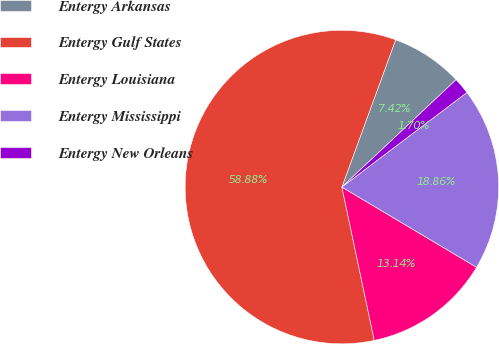<chart> <loc_0><loc_0><loc_500><loc_500><pie_chart><fcel>Entergy Arkansas<fcel>Entergy Gulf States<fcel>Entergy Louisiana<fcel>Entergy Mississippi<fcel>Entergy New Orleans<nl><fcel>7.42%<fcel>58.89%<fcel>13.14%<fcel>18.86%<fcel>1.7%<nl></chart> 